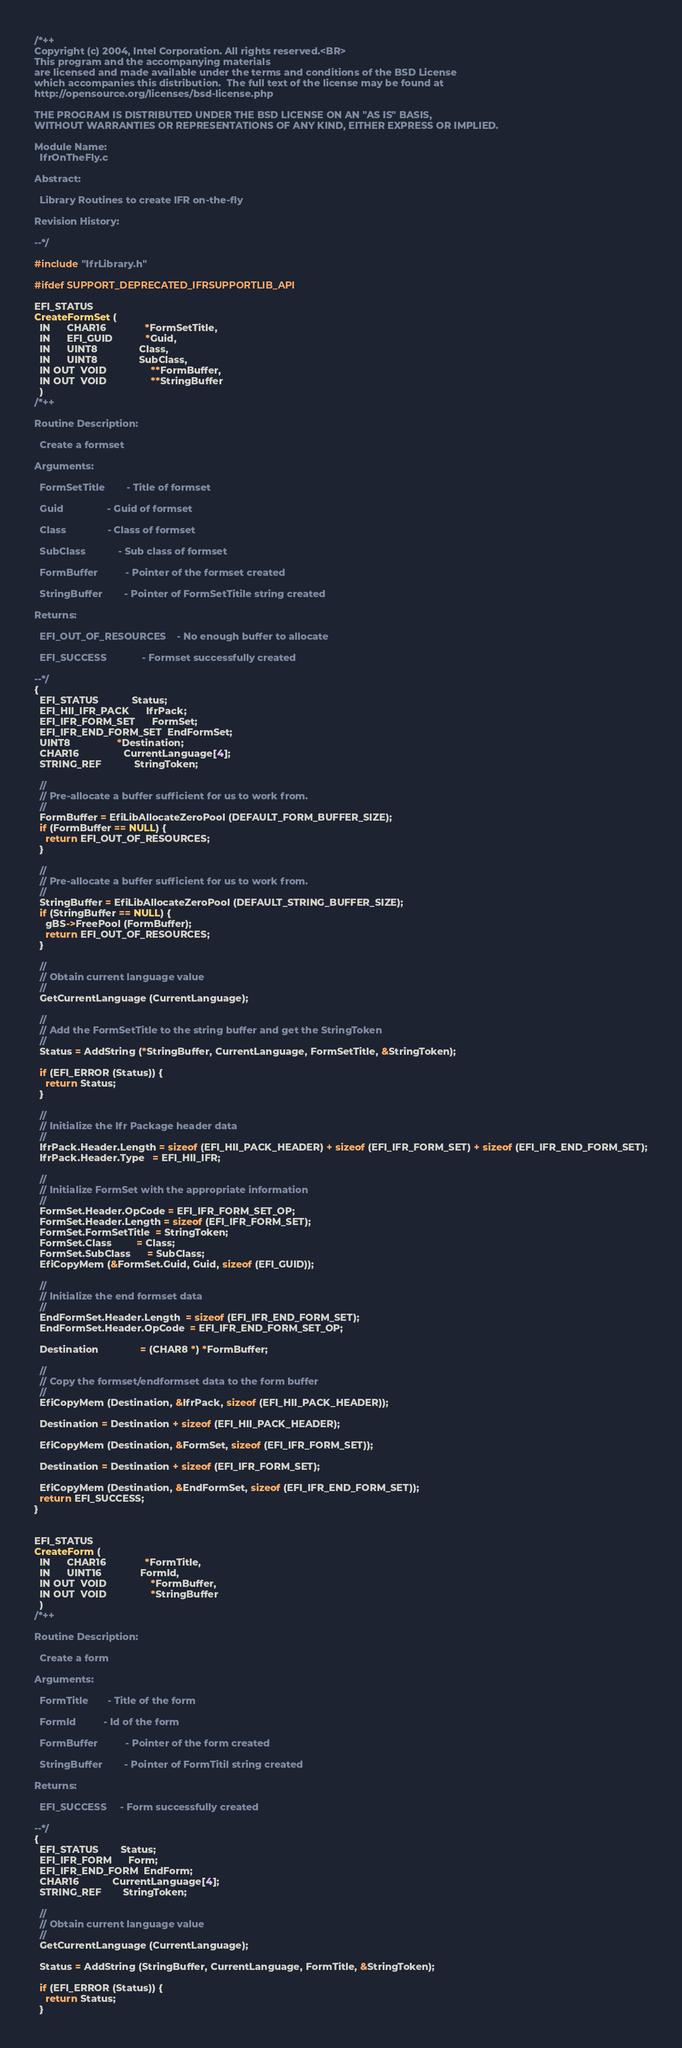<code> <loc_0><loc_0><loc_500><loc_500><_C_>/*++
Copyright (c) 2004, Intel Corporation. All rights reserved.<BR>
This program and the accompanying materials                          
are licensed and made available under the terms and conditions of the BSD License         
which accompanies this distribution.  The full text of the license may be found at        
http://opensource.org/licenses/bsd-license.php                                            
                                                                                          
THE PROGRAM IS DISTRIBUTED UNDER THE BSD LICENSE ON AN "AS IS" BASIS,                     
WITHOUT WARRANTIES OR REPRESENTATIONS OF ANY KIND, EITHER EXPRESS OR IMPLIED.             

Module Name:
  IfrOnTheFly.c

Abstract:

  Library Routines to create IFR on-the-fly

Revision History:

--*/

#include "IfrLibrary.h"

#ifdef SUPPORT_DEPRECATED_IFRSUPPORTLIB_API

EFI_STATUS
CreateFormSet (
  IN      CHAR16              *FormSetTitle,
  IN      EFI_GUID            *Guid,
  IN      UINT8               Class,
  IN      UINT8               SubClass,
  IN OUT  VOID                **FormBuffer,
  IN OUT  VOID                **StringBuffer
  )
/*++

Routine Description:

  Create a formset
  
Arguments:
  
  FormSetTitle        - Title of formset
  
  Guid                - Guid of formset
  
  Class               - Class of formset
  
  SubClass            - Sub class of formset
  
  FormBuffer          - Pointer of the formset created
  
  StringBuffer        - Pointer of FormSetTitile string created
  
Returns: 

  EFI_OUT_OF_RESOURCES    - No enough buffer to allocate
  
  EFI_SUCCESS             - Formset successfully created

--*/
{
  EFI_STATUS            Status;
  EFI_HII_IFR_PACK      IfrPack;
  EFI_IFR_FORM_SET      FormSet;
  EFI_IFR_END_FORM_SET  EndFormSet;
  UINT8                 *Destination;
  CHAR16                CurrentLanguage[4];
  STRING_REF            StringToken;

  //
  // Pre-allocate a buffer sufficient for us to work from.
  //
  FormBuffer = EfiLibAllocateZeroPool (DEFAULT_FORM_BUFFER_SIZE);
  if (FormBuffer == NULL) {
    return EFI_OUT_OF_RESOURCES;
  }

  //
  // Pre-allocate a buffer sufficient for us to work from.
  //
  StringBuffer = EfiLibAllocateZeroPool (DEFAULT_STRING_BUFFER_SIZE);
  if (StringBuffer == NULL) {
    gBS->FreePool (FormBuffer);
    return EFI_OUT_OF_RESOURCES;
  }

  //
  // Obtain current language value
  //
  GetCurrentLanguage (CurrentLanguage);

  //
  // Add the FormSetTitle to the string buffer and get the StringToken
  //
  Status = AddString (*StringBuffer, CurrentLanguage, FormSetTitle, &StringToken);

  if (EFI_ERROR (Status)) {
    return Status;
  }

  //
  // Initialize the Ifr Package header data
  //
  IfrPack.Header.Length = sizeof (EFI_HII_PACK_HEADER) + sizeof (EFI_IFR_FORM_SET) + sizeof (EFI_IFR_END_FORM_SET);
  IfrPack.Header.Type   = EFI_HII_IFR;

  //
  // Initialize FormSet with the appropriate information
  //
  FormSet.Header.OpCode = EFI_IFR_FORM_SET_OP;
  FormSet.Header.Length = sizeof (EFI_IFR_FORM_SET);
  FormSet.FormSetTitle  = StringToken;
  FormSet.Class         = Class;
  FormSet.SubClass      = SubClass;
  EfiCopyMem (&FormSet.Guid, Guid, sizeof (EFI_GUID));

  //
  // Initialize the end formset data
  //
  EndFormSet.Header.Length  = sizeof (EFI_IFR_END_FORM_SET);
  EndFormSet.Header.OpCode  = EFI_IFR_END_FORM_SET_OP;

  Destination               = (CHAR8 *) *FormBuffer;

  //
  // Copy the formset/endformset data to the form buffer
  //
  EfiCopyMem (Destination, &IfrPack, sizeof (EFI_HII_PACK_HEADER));

  Destination = Destination + sizeof (EFI_HII_PACK_HEADER);

  EfiCopyMem (Destination, &FormSet, sizeof (EFI_IFR_FORM_SET));

  Destination = Destination + sizeof (EFI_IFR_FORM_SET);

  EfiCopyMem (Destination, &EndFormSet, sizeof (EFI_IFR_END_FORM_SET));
  return EFI_SUCCESS;
}


EFI_STATUS
CreateForm (
  IN      CHAR16              *FormTitle,
  IN      UINT16              FormId,
  IN OUT  VOID                *FormBuffer,
  IN OUT  VOID                *StringBuffer
  )
/*++

Routine Description:

  Create a form
  
Arguments:
  
  FormTitle       - Title of the form
  
  FormId          - Id of the form
  
  FormBuffer          - Pointer of the form created
  
  StringBuffer        - Pointer of FormTitil string created
  
Returns: 

  EFI_SUCCESS     - Form successfully created

--*/
{
  EFI_STATUS        Status;
  EFI_IFR_FORM      Form;
  EFI_IFR_END_FORM  EndForm;
  CHAR16            CurrentLanguage[4];
  STRING_REF        StringToken;

  //
  // Obtain current language value
  //
  GetCurrentLanguage (CurrentLanguage);

  Status = AddString (StringBuffer, CurrentLanguage, FormTitle, &StringToken);

  if (EFI_ERROR (Status)) {
    return Status;
  }
</code> 